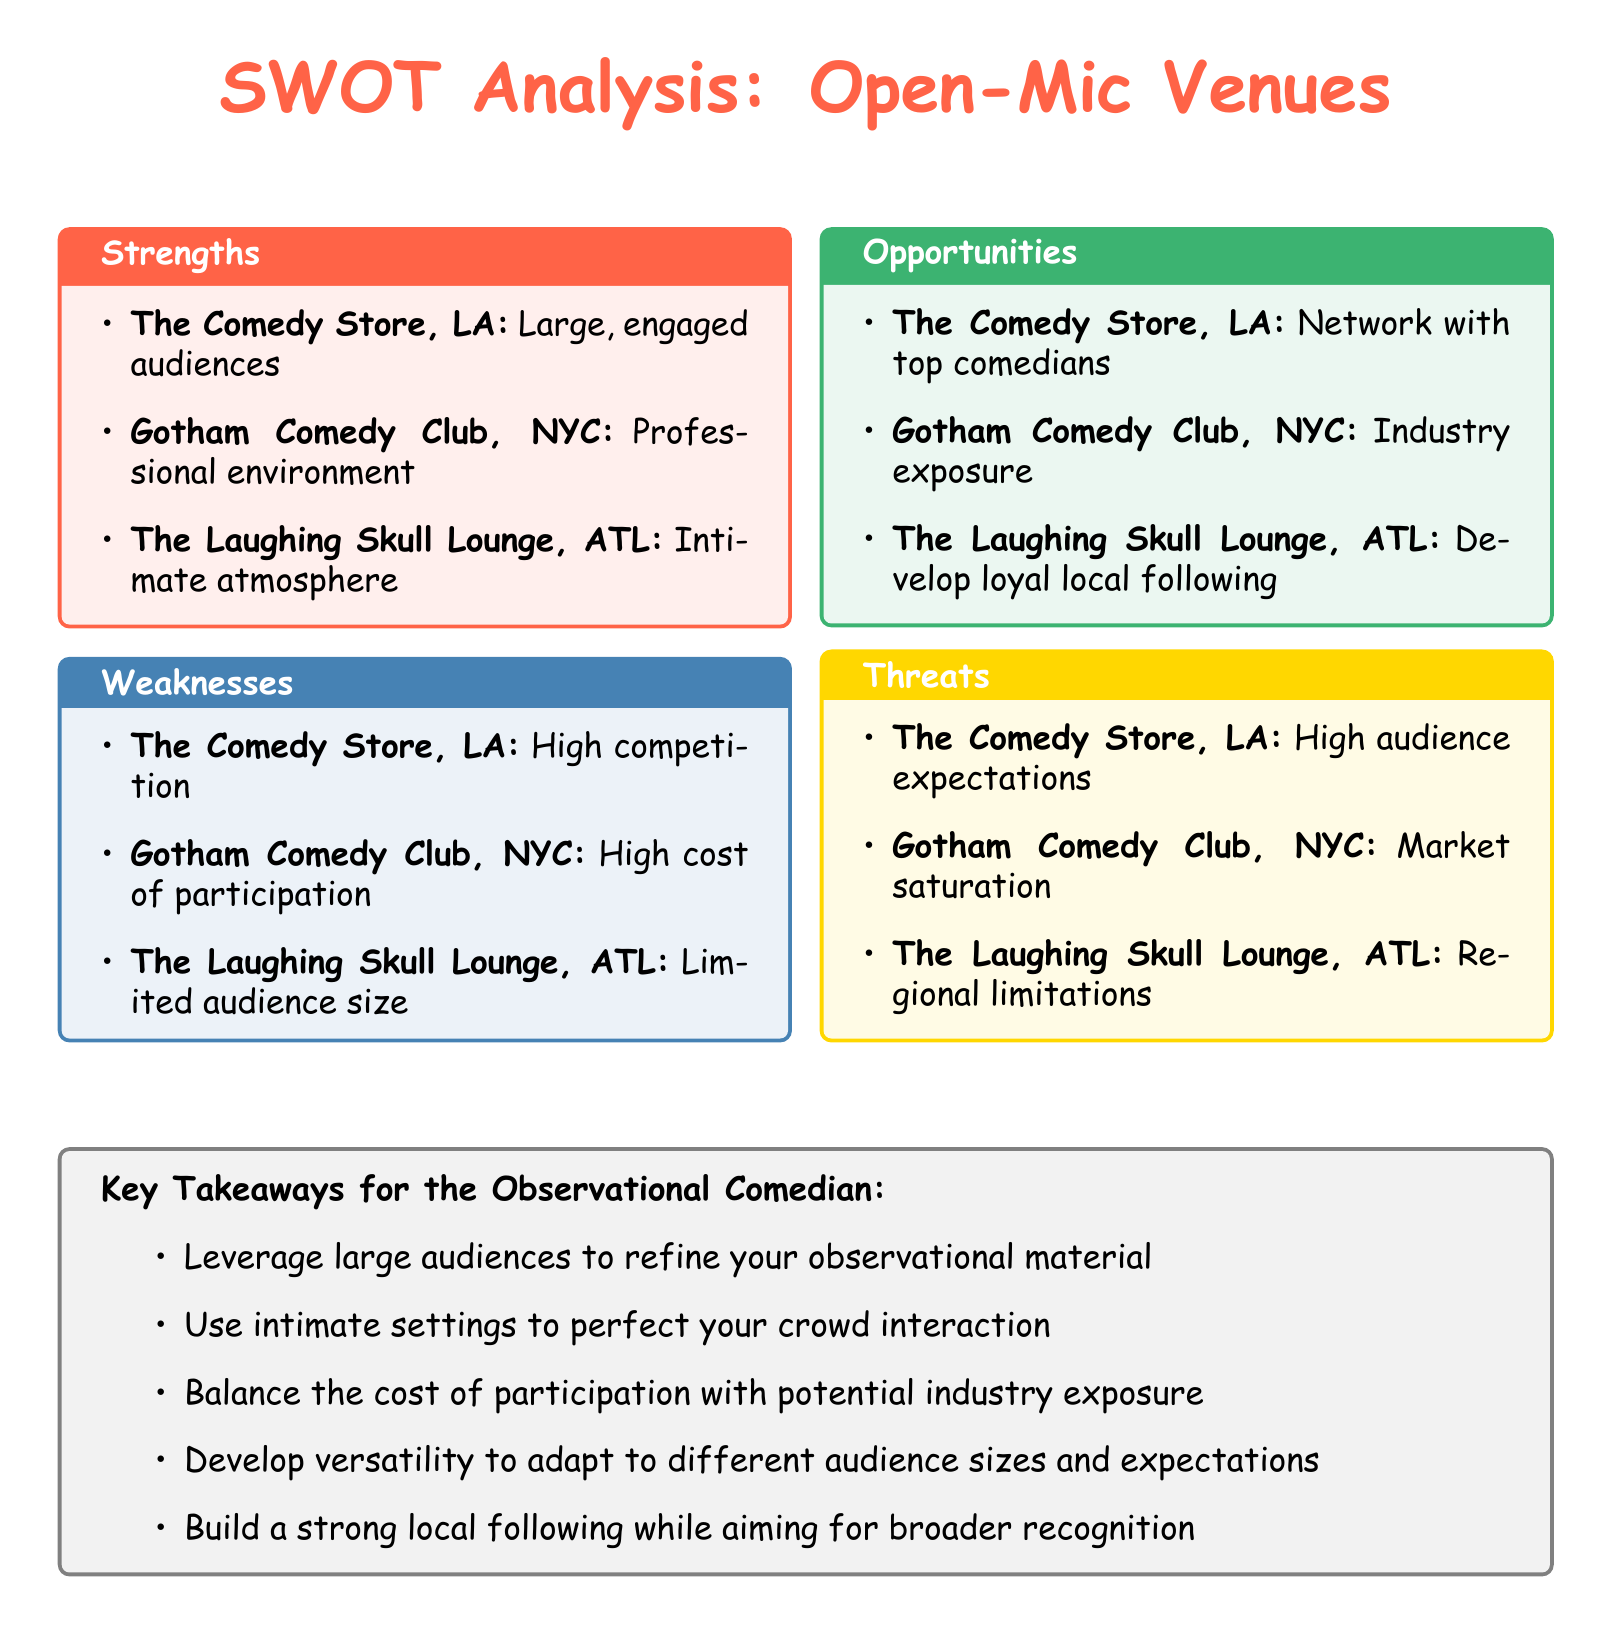What is a strength of The Comedy Store in LA? The strength listed for The Comedy Store in LA is its large, engaged audiences.
Answer: Large, engaged audiences What is a weakness of Gotham Comedy Club in NYC? The weakness listed for Gotham Comedy Club in NYC is the high cost of participation.
Answer: High cost of participation What opportunity does The Laughing Skull Lounge in ATL offer? An opportunity for The Laughing Skull Lounge in ATL is to develop a loyal local following.
Answer: Develop loyal local following What threat is associated with the Comedy Store in LA? The threat associated with the Comedy Store in LA is high audience expectations.
Answer: High audience expectations How many open-mic venues are analyzed in the document? The document lists three open-mic venues.
Answer: Three What type of atmosphere does The Laughing Skull Lounge in ATL provide? The type of atmosphere provided by The Laughing Skull Lounge in ATL is intimate.
Answer: Intimate atmosphere What key takeaway emphasizes crowd interaction? The key takeaway that emphasizes crowd interaction is to use intimate settings to perfect your crowd interaction.
Answer: Perfect your crowd interaction Which city has a venue with professional environment? The city with a venue that has a professional environment is NYC.
Answer: NYC 